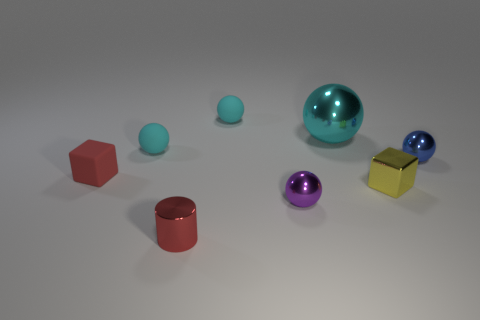Is the material of the big thing the same as the ball that is in front of the red rubber block?
Keep it short and to the point. Yes. What color is the metallic cylinder?
Offer a terse response. Red. What number of big cyan spheres are behind the block that is left of the cyan matte thing that is in front of the large cyan thing?
Offer a terse response. 1. Are there any tiny red shiny things to the right of the tiny purple object?
Provide a succinct answer. No. How many small yellow cylinders have the same material as the small yellow cube?
Your answer should be very brief. 0. How many things are red metal cylinders or matte spheres?
Provide a short and direct response. 3. Are there any yellow cubes?
Ensure brevity in your answer.  Yes. What material is the cyan object behind the cyan sphere on the right side of the tiny rubber sphere behind the big shiny object?
Give a very brief answer. Rubber. Is the number of tiny spheres in front of the small red cube less than the number of yellow things?
Provide a short and direct response. No. What material is the blue thing that is the same size as the yellow cube?
Make the answer very short. Metal. 